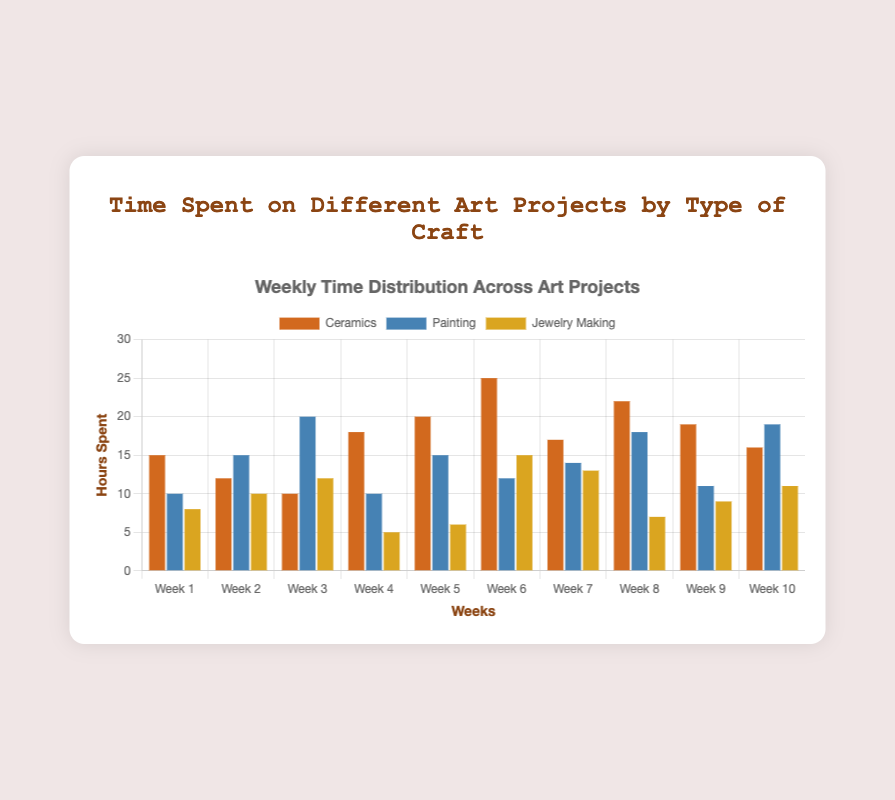What week did you spend the most time on ceramics? Check for the tallest bar corresponding to the Ceramics dataset across all weeks. The tallest bar is in Week 6.
Answer: Week 6 In which week was the time spent on painting the highest? Look for the highest bar associated with the Painting category. The highest bar is in Week 3.
Answer: Week 3 How many weeks did you spend 15 or more hours on ceramics? Count the number of weeks where the Ceramics bars are at 15 hours or higher. These are: Week 1, Week 5, Week 6, Week 7, Week 8, Week 9, and Week 10.
Answer: 7 Which week shows the highest combined hours across all crafts? Add up the hours for all crafts each week and compare the sums. Week 6 has the highest combined total with 52 hours (Ceramics: 25, Painting: 12, Jewelry Making: 15).
Answer: Week 6 What is the average time spent on jewelry making per week? Sum up all the hours spent on Jewelry Making over the 10 weeks and divide by 10. The sum is 96, so the average is 96/10 = 9.6.
Answer: 9.6 In which week was the time spent on ceramics more than the combined time spent on the other two crafts? For each week, check if the Ceramics bar height is greater than the sum of the Painting and Jewelry Making bars. In Week 4, Ceramics (18) is greater than Painting (10) + Jewelry Making (5). In Week 6, Ceramics (25) is greater than Painting (12) + Jewelry Making (15). In Week 8, Ceramics (22) is greater than Painting (18) + Jewelry Making (7).
Answer: Week 4, Week 6, Week 8 Compare the hours spent on painting between Week 2 and Week 9, which week had more hours? Look at the Painting bars for Week 2 and Week 9. Week 2 has 15 hours, and Week 9 has 11 hours.
Answer: Week 2 Identify the week where the hours spent on all three types of crafts were equal. Look for weeks where Ceramics, Painting, and Jewelry Making bars are of the same height. No week showing this condition.
Answer: None 